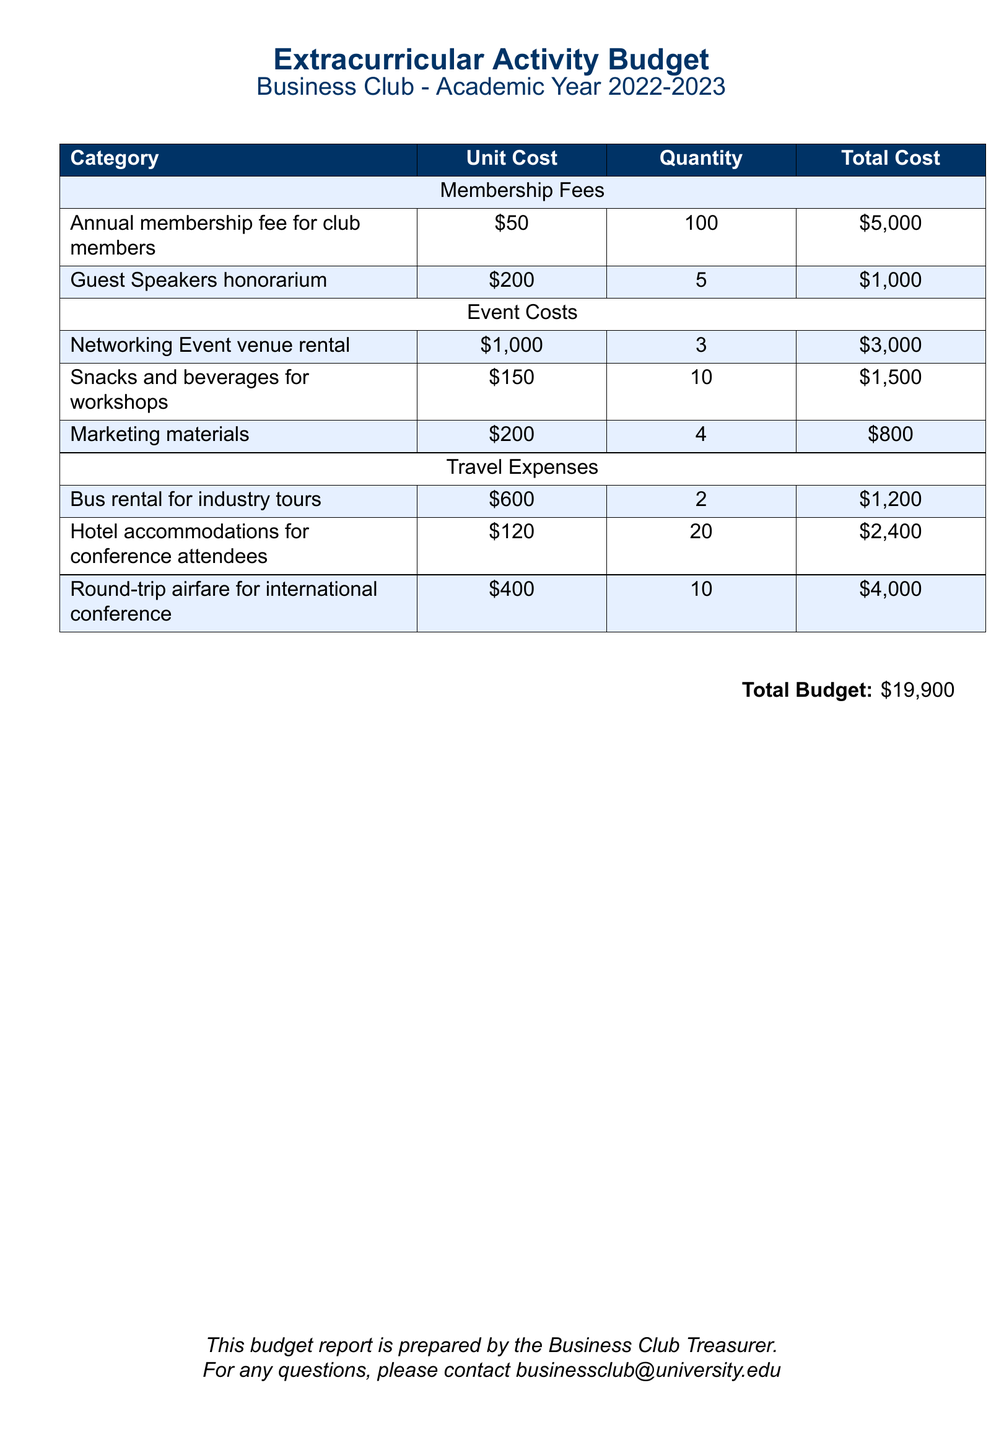What is the total cost of membership fees? The total cost of membership fees is calculated by summing the annual membership fee and the guest speakers' honorarium, which is $5000 + $1000 = $6000.
Answer: $6000 How many networking events were held? The number of networking events can be found in the event costs section, which states 3 networking events were held.
Answer: 3 What is the unit cost for hotel accommodations? The unit cost for hotel accommodations is specified in the travel expenses section, which shows $120 per room.
Answer: $120 What is the total budget? The total budget is provided at the bottom of the document, which sums up all categories of expenses to $19,900.
Answer: $19,900 What is the quantity of snacks and beverages purchased? The quantity of snacks and beverages purchased is listed in event costs, which shows 10 units purchased.
Answer: 10 How much was spent on round-trip airfare? The total cost for round-trip airfare is listed under travel expenses, which shows a total of $4,000.
Answer: $4,000 What is the total cost for marketing materials? The total cost for marketing materials can be found in the event costs section, where it states the total is $800.
Answer: $800 How many guest speakers were invited? The total number of guest speakers invited is noted as 5 in the membership fees section.
Answer: 5 What were the total travel expenses? The total travel expenses can be calculated by summing the individual travel costs: bus rental $1,200 + hotel accommodations $2,400 + airfare $4,000 = $7,600.
Answer: $7,600 